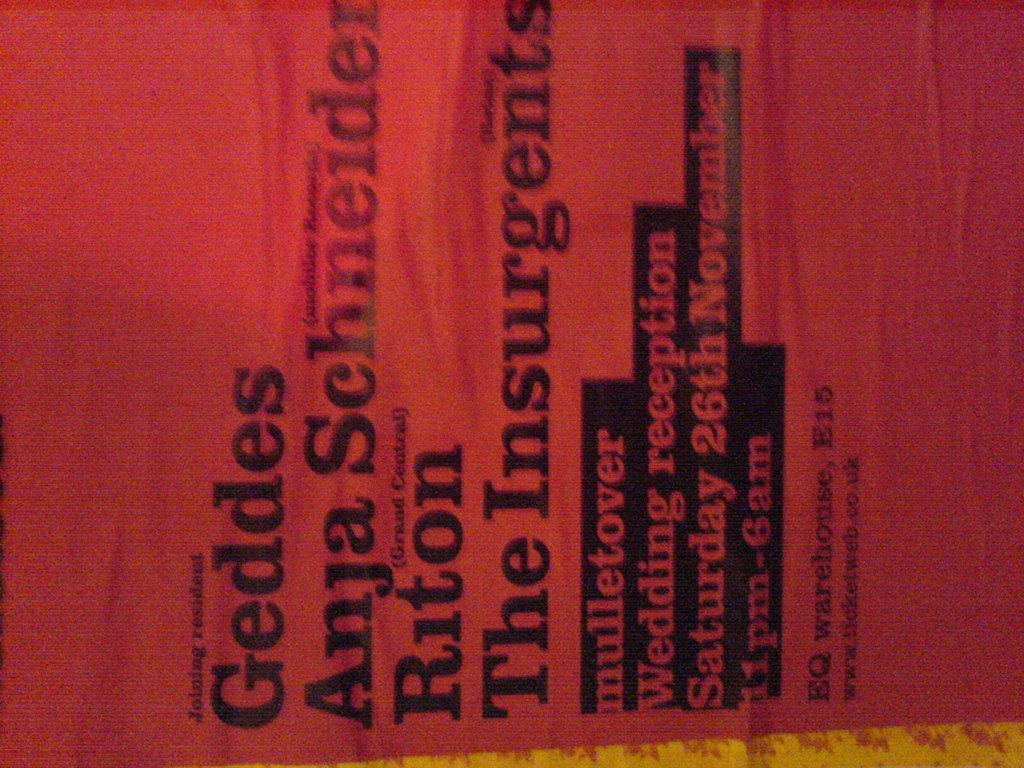<image>
Render a clear and concise summary of the photo. a cloth that says 'geddes anja schneid' on it 